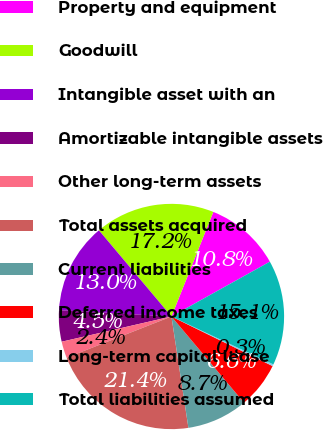<chart> <loc_0><loc_0><loc_500><loc_500><pie_chart><fcel>Property and equipment<fcel>Goodwill<fcel>Intangible asset with an<fcel>Amortizable intangible assets<fcel>Other long-term assets<fcel>Total assets acquired<fcel>Current liabilities<fcel>Deferred income taxes<fcel>Long-term capital lease<fcel>Total liabilities assumed<nl><fcel>10.85%<fcel>17.2%<fcel>12.97%<fcel>4.49%<fcel>2.37%<fcel>21.44%<fcel>8.73%<fcel>6.61%<fcel>0.26%<fcel>15.08%<nl></chart> 